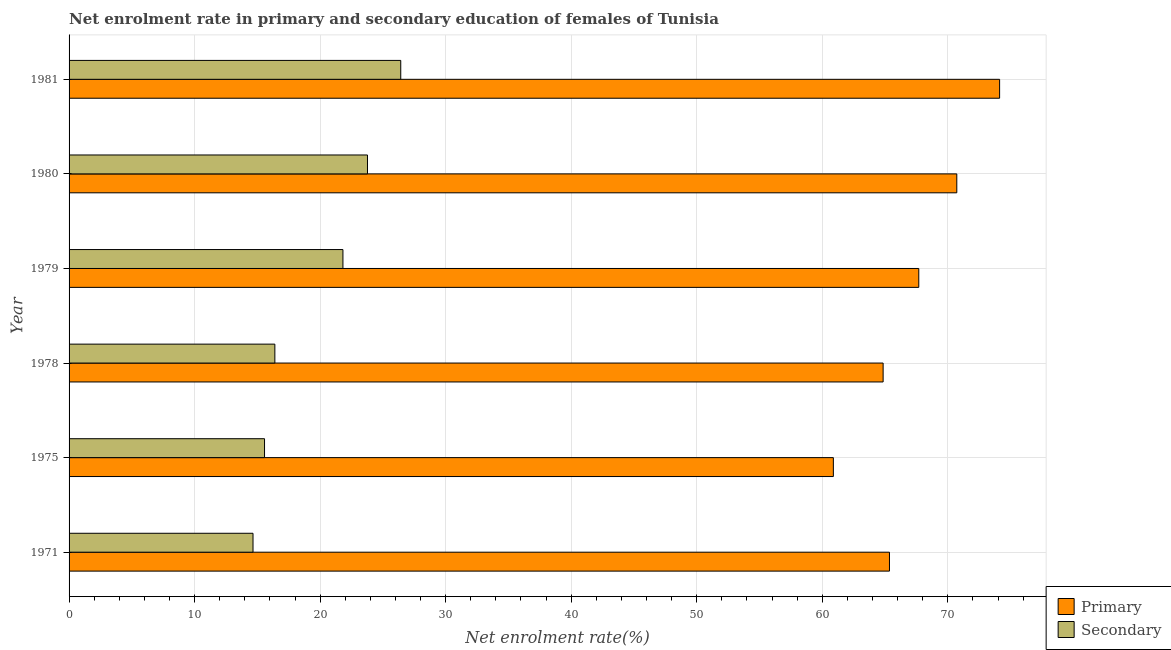How many different coloured bars are there?
Keep it short and to the point. 2. Are the number of bars on each tick of the Y-axis equal?
Keep it short and to the point. Yes. How many bars are there on the 6th tick from the bottom?
Keep it short and to the point. 2. What is the label of the 3rd group of bars from the top?
Provide a short and direct response. 1979. In how many cases, is the number of bars for a given year not equal to the number of legend labels?
Your response must be concise. 0. What is the enrollment rate in secondary education in 1971?
Your response must be concise. 14.65. Across all years, what is the maximum enrollment rate in primary education?
Ensure brevity in your answer.  74.13. Across all years, what is the minimum enrollment rate in primary education?
Offer a very short reply. 60.88. In which year was the enrollment rate in secondary education maximum?
Your answer should be compact. 1981. In which year was the enrollment rate in secondary education minimum?
Your response must be concise. 1971. What is the total enrollment rate in primary education in the graph?
Offer a very short reply. 403.62. What is the difference between the enrollment rate in secondary education in 1978 and that in 1980?
Ensure brevity in your answer.  -7.38. What is the difference between the enrollment rate in primary education in 1979 and the enrollment rate in secondary education in 1980?
Offer a very short reply. 43.92. What is the average enrollment rate in secondary education per year?
Make the answer very short. 19.77. In the year 1979, what is the difference between the enrollment rate in primary education and enrollment rate in secondary education?
Your response must be concise. 45.87. In how many years, is the enrollment rate in primary education greater than 60 %?
Provide a succinct answer. 6. What is the ratio of the enrollment rate in secondary education in 1978 to that in 1979?
Give a very brief answer. 0.75. What is the difference between the highest and the second highest enrollment rate in secondary education?
Provide a short and direct response. 2.65. What is the difference between the highest and the lowest enrollment rate in primary education?
Ensure brevity in your answer.  13.24. In how many years, is the enrollment rate in secondary education greater than the average enrollment rate in secondary education taken over all years?
Provide a short and direct response. 3. What does the 2nd bar from the top in 1975 represents?
Your answer should be very brief. Primary. What does the 1st bar from the bottom in 1979 represents?
Give a very brief answer. Primary. How many years are there in the graph?
Provide a short and direct response. 6. What is the difference between two consecutive major ticks on the X-axis?
Your response must be concise. 10. Does the graph contain any zero values?
Your response must be concise. No. Does the graph contain grids?
Your answer should be compact. Yes. Where does the legend appear in the graph?
Your answer should be compact. Bottom right. How many legend labels are there?
Provide a short and direct response. 2. How are the legend labels stacked?
Give a very brief answer. Vertical. What is the title of the graph?
Ensure brevity in your answer.  Net enrolment rate in primary and secondary education of females of Tunisia. What is the label or title of the X-axis?
Your answer should be compact. Net enrolment rate(%). What is the Net enrolment rate(%) of Primary in 1971?
Keep it short and to the point. 65.35. What is the Net enrolment rate(%) in Secondary in 1971?
Provide a short and direct response. 14.65. What is the Net enrolment rate(%) of Primary in 1975?
Offer a very short reply. 60.88. What is the Net enrolment rate(%) in Secondary in 1975?
Ensure brevity in your answer.  15.57. What is the Net enrolment rate(%) of Primary in 1978?
Offer a terse response. 64.85. What is the Net enrolment rate(%) in Secondary in 1978?
Provide a succinct answer. 16.39. What is the Net enrolment rate(%) of Primary in 1979?
Give a very brief answer. 67.69. What is the Net enrolment rate(%) of Secondary in 1979?
Offer a very short reply. 21.82. What is the Net enrolment rate(%) of Primary in 1980?
Offer a terse response. 70.72. What is the Net enrolment rate(%) of Secondary in 1980?
Offer a terse response. 23.77. What is the Net enrolment rate(%) in Primary in 1981?
Your answer should be very brief. 74.13. What is the Net enrolment rate(%) of Secondary in 1981?
Your answer should be very brief. 26.42. Across all years, what is the maximum Net enrolment rate(%) of Primary?
Your response must be concise. 74.13. Across all years, what is the maximum Net enrolment rate(%) of Secondary?
Provide a succinct answer. 26.42. Across all years, what is the minimum Net enrolment rate(%) of Primary?
Provide a short and direct response. 60.88. Across all years, what is the minimum Net enrolment rate(%) of Secondary?
Make the answer very short. 14.65. What is the total Net enrolment rate(%) in Primary in the graph?
Make the answer very short. 403.62. What is the total Net enrolment rate(%) in Secondary in the graph?
Offer a terse response. 118.63. What is the difference between the Net enrolment rate(%) in Primary in 1971 and that in 1975?
Your answer should be compact. 4.47. What is the difference between the Net enrolment rate(%) in Secondary in 1971 and that in 1975?
Make the answer very short. -0.92. What is the difference between the Net enrolment rate(%) in Primary in 1971 and that in 1978?
Offer a very short reply. 0.51. What is the difference between the Net enrolment rate(%) of Secondary in 1971 and that in 1978?
Offer a terse response. -1.74. What is the difference between the Net enrolment rate(%) in Primary in 1971 and that in 1979?
Give a very brief answer. -2.34. What is the difference between the Net enrolment rate(%) in Secondary in 1971 and that in 1979?
Offer a terse response. -7.16. What is the difference between the Net enrolment rate(%) of Primary in 1971 and that in 1980?
Ensure brevity in your answer.  -5.36. What is the difference between the Net enrolment rate(%) of Secondary in 1971 and that in 1980?
Ensure brevity in your answer.  -9.12. What is the difference between the Net enrolment rate(%) in Primary in 1971 and that in 1981?
Give a very brief answer. -8.77. What is the difference between the Net enrolment rate(%) of Secondary in 1971 and that in 1981?
Give a very brief answer. -11.77. What is the difference between the Net enrolment rate(%) of Primary in 1975 and that in 1978?
Provide a succinct answer. -3.96. What is the difference between the Net enrolment rate(%) of Secondary in 1975 and that in 1978?
Provide a short and direct response. -0.82. What is the difference between the Net enrolment rate(%) of Primary in 1975 and that in 1979?
Ensure brevity in your answer.  -6.8. What is the difference between the Net enrolment rate(%) in Secondary in 1975 and that in 1979?
Give a very brief answer. -6.25. What is the difference between the Net enrolment rate(%) of Primary in 1975 and that in 1980?
Make the answer very short. -9.83. What is the difference between the Net enrolment rate(%) of Secondary in 1975 and that in 1980?
Provide a short and direct response. -8.2. What is the difference between the Net enrolment rate(%) in Primary in 1975 and that in 1981?
Your response must be concise. -13.24. What is the difference between the Net enrolment rate(%) of Secondary in 1975 and that in 1981?
Your response must be concise. -10.85. What is the difference between the Net enrolment rate(%) in Primary in 1978 and that in 1979?
Ensure brevity in your answer.  -2.84. What is the difference between the Net enrolment rate(%) in Secondary in 1978 and that in 1979?
Your response must be concise. -5.42. What is the difference between the Net enrolment rate(%) of Primary in 1978 and that in 1980?
Provide a short and direct response. -5.87. What is the difference between the Net enrolment rate(%) in Secondary in 1978 and that in 1980?
Ensure brevity in your answer.  -7.38. What is the difference between the Net enrolment rate(%) of Primary in 1978 and that in 1981?
Offer a very short reply. -9.28. What is the difference between the Net enrolment rate(%) of Secondary in 1978 and that in 1981?
Provide a short and direct response. -10.03. What is the difference between the Net enrolment rate(%) of Primary in 1979 and that in 1980?
Make the answer very short. -3.03. What is the difference between the Net enrolment rate(%) in Secondary in 1979 and that in 1980?
Your answer should be compact. -1.96. What is the difference between the Net enrolment rate(%) in Primary in 1979 and that in 1981?
Keep it short and to the point. -6.44. What is the difference between the Net enrolment rate(%) of Secondary in 1979 and that in 1981?
Offer a terse response. -4.61. What is the difference between the Net enrolment rate(%) in Primary in 1980 and that in 1981?
Your answer should be very brief. -3.41. What is the difference between the Net enrolment rate(%) in Secondary in 1980 and that in 1981?
Offer a very short reply. -2.65. What is the difference between the Net enrolment rate(%) in Primary in 1971 and the Net enrolment rate(%) in Secondary in 1975?
Offer a very short reply. 49.78. What is the difference between the Net enrolment rate(%) of Primary in 1971 and the Net enrolment rate(%) of Secondary in 1978?
Provide a short and direct response. 48.96. What is the difference between the Net enrolment rate(%) of Primary in 1971 and the Net enrolment rate(%) of Secondary in 1979?
Give a very brief answer. 43.54. What is the difference between the Net enrolment rate(%) in Primary in 1971 and the Net enrolment rate(%) in Secondary in 1980?
Keep it short and to the point. 41.58. What is the difference between the Net enrolment rate(%) in Primary in 1971 and the Net enrolment rate(%) in Secondary in 1981?
Your response must be concise. 38.93. What is the difference between the Net enrolment rate(%) of Primary in 1975 and the Net enrolment rate(%) of Secondary in 1978?
Provide a short and direct response. 44.49. What is the difference between the Net enrolment rate(%) of Primary in 1975 and the Net enrolment rate(%) of Secondary in 1979?
Offer a terse response. 39.07. What is the difference between the Net enrolment rate(%) of Primary in 1975 and the Net enrolment rate(%) of Secondary in 1980?
Make the answer very short. 37.11. What is the difference between the Net enrolment rate(%) of Primary in 1975 and the Net enrolment rate(%) of Secondary in 1981?
Give a very brief answer. 34.46. What is the difference between the Net enrolment rate(%) of Primary in 1978 and the Net enrolment rate(%) of Secondary in 1979?
Your answer should be very brief. 43.03. What is the difference between the Net enrolment rate(%) in Primary in 1978 and the Net enrolment rate(%) in Secondary in 1980?
Your answer should be compact. 41.08. What is the difference between the Net enrolment rate(%) in Primary in 1978 and the Net enrolment rate(%) in Secondary in 1981?
Give a very brief answer. 38.43. What is the difference between the Net enrolment rate(%) of Primary in 1979 and the Net enrolment rate(%) of Secondary in 1980?
Provide a succinct answer. 43.92. What is the difference between the Net enrolment rate(%) in Primary in 1979 and the Net enrolment rate(%) in Secondary in 1981?
Provide a short and direct response. 41.27. What is the difference between the Net enrolment rate(%) of Primary in 1980 and the Net enrolment rate(%) of Secondary in 1981?
Your response must be concise. 44.3. What is the average Net enrolment rate(%) in Primary per year?
Keep it short and to the point. 67.27. What is the average Net enrolment rate(%) of Secondary per year?
Your answer should be compact. 19.77. In the year 1971, what is the difference between the Net enrolment rate(%) of Primary and Net enrolment rate(%) of Secondary?
Your answer should be compact. 50.7. In the year 1975, what is the difference between the Net enrolment rate(%) in Primary and Net enrolment rate(%) in Secondary?
Give a very brief answer. 45.31. In the year 1978, what is the difference between the Net enrolment rate(%) of Primary and Net enrolment rate(%) of Secondary?
Offer a terse response. 48.46. In the year 1979, what is the difference between the Net enrolment rate(%) of Primary and Net enrolment rate(%) of Secondary?
Keep it short and to the point. 45.87. In the year 1980, what is the difference between the Net enrolment rate(%) of Primary and Net enrolment rate(%) of Secondary?
Offer a terse response. 46.95. In the year 1981, what is the difference between the Net enrolment rate(%) in Primary and Net enrolment rate(%) in Secondary?
Your answer should be very brief. 47.71. What is the ratio of the Net enrolment rate(%) in Primary in 1971 to that in 1975?
Ensure brevity in your answer.  1.07. What is the ratio of the Net enrolment rate(%) of Secondary in 1971 to that in 1975?
Provide a short and direct response. 0.94. What is the ratio of the Net enrolment rate(%) of Primary in 1971 to that in 1978?
Give a very brief answer. 1.01. What is the ratio of the Net enrolment rate(%) of Secondary in 1971 to that in 1978?
Provide a succinct answer. 0.89. What is the ratio of the Net enrolment rate(%) in Primary in 1971 to that in 1979?
Make the answer very short. 0.97. What is the ratio of the Net enrolment rate(%) of Secondary in 1971 to that in 1979?
Give a very brief answer. 0.67. What is the ratio of the Net enrolment rate(%) in Primary in 1971 to that in 1980?
Give a very brief answer. 0.92. What is the ratio of the Net enrolment rate(%) of Secondary in 1971 to that in 1980?
Make the answer very short. 0.62. What is the ratio of the Net enrolment rate(%) in Primary in 1971 to that in 1981?
Ensure brevity in your answer.  0.88. What is the ratio of the Net enrolment rate(%) of Secondary in 1971 to that in 1981?
Your answer should be compact. 0.55. What is the ratio of the Net enrolment rate(%) of Primary in 1975 to that in 1978?
Provide a short and direct response. 0.94. What is the ratio of the Net enrolment rate(%) of Secondary in 1975 to that in 1978?
Your answer should be compact. 0.95. What is the ratio of the Net enrolment rate(%) in Primary in 1975 to that in 1979?
Provide a succinct answer. 0.9. What is the ratio of the Net enrolment rate(%) in Secondary in 1975 to that in 1979?
Keep it short and to the point. 0.71. What is the ratio of the Net enrolment rate(%) in Primary in 1975 to that in 1980?
Provide a short and direct response. 0.86. What is the ratio of the Net enrolment rate(%) in Secondary in 1975 to that in 1980?
Keep it short and to the point. 0.66. What is the ratio of the Net enrolment rate(%) of Primary in 1975 to that in 1981?
Provide a short and direct response. 0.82. What is the ratio of the Net enrolment rate(%) of Secondary in 1975 to that in 1981?
Your answer should be compact. 0.59. What is the ratio of the Net enrolment rate(%) in Primary in 1978 to that in 1979?
Keep it short and to the point. 0.96. What is the ratio of the Net enrolment rate(%) in Secondary in 1978 to that in 1979?
Keep it short and to the point. 0.75. What is the ratio of the Net enrolment rate(%) in Primary in 1978 to that in 1980?
Ensure brevity in your answer.  0.92. What is the ratio of the Net enrolment rate(%) of Secondary in 1978 to that in 1980?
Provide a succinct answer. 0.69. What is the ratio of the Net enrolment rate(%) in Primary in 1978 to that in 1981?
Make the answer very short. 0.87. What is the ratio of the Net enrolment rate(%) in Secondary in 1978 to that in 1981?
Your answer should be compact. 0.62. What is the ratio of the Net enrolment rate(%) in Primary in 1979 to that in 1980?
Ensure brevity in your answer.  0.96. What is the ratio of the Net enrolment rate(%) of Secondary in 1979 to that in 1980?
Provide a short and direct response. 0.92. What is the ratio of the Net enrolment rate(%) of Primary in 1979 to that in 1981?
Your answer should be compact. 0.91. What is the ratio of the Net enrolment rate(%) of Secondary in 1979 to that in 1981?
Your answer should be compact. 0.83. What is the ratio of the Net enrolment rate(%) of Primary in 1980 to that in 1981?
Provide a succinct answer. 0.95. What is the ratio of the Net enrolment rate(%) in Secondary in 1980 to that in 1981?
Ensure brevity in your answer.  0.9. What is the difference between the highest and the second highest Net enrolment rate(%) of Primary?
Offer a very short reply. 3.41. What is the difference between the highest and the second highest Net enrolment rate(%) in Secondary?
Your response must be concise. 2.65. What is the difference between the highest and the lowest Net enrolment rate(%) of Primary?
Offer a very short reply. 13.24. What is the difference between the highest and the lowest Net enrolment rate(%) of Secondary?
Ensure brevity in your answer.  11.77. 